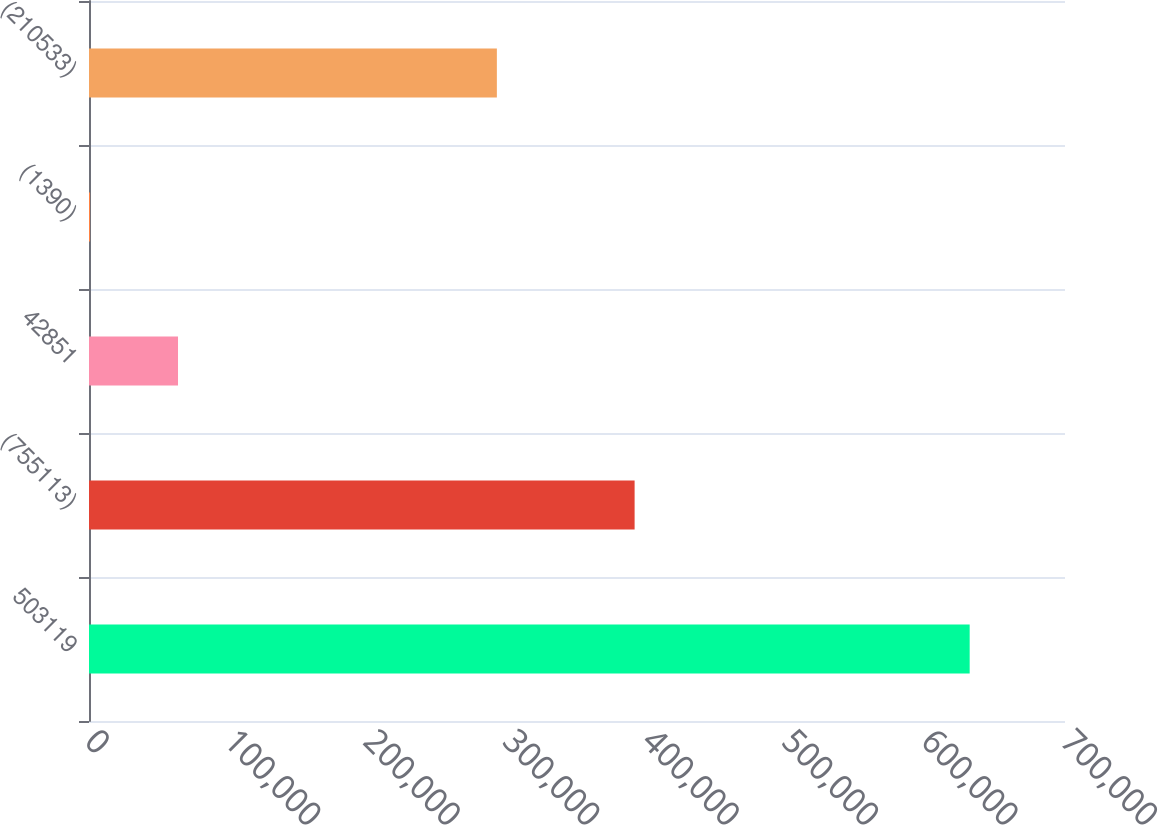Convert chart to OTSL. <chart><loc_0><loc_0><loc_500><loc_500><bar_chart><fcel>503119<fcel>(755113)<fcel>42851<fcel>(1390)<fcel>(210533)<nl><fcel>631627<fcel>391320<fcel>63840.4<fcel>753<fcel>292529<nl></chart> 